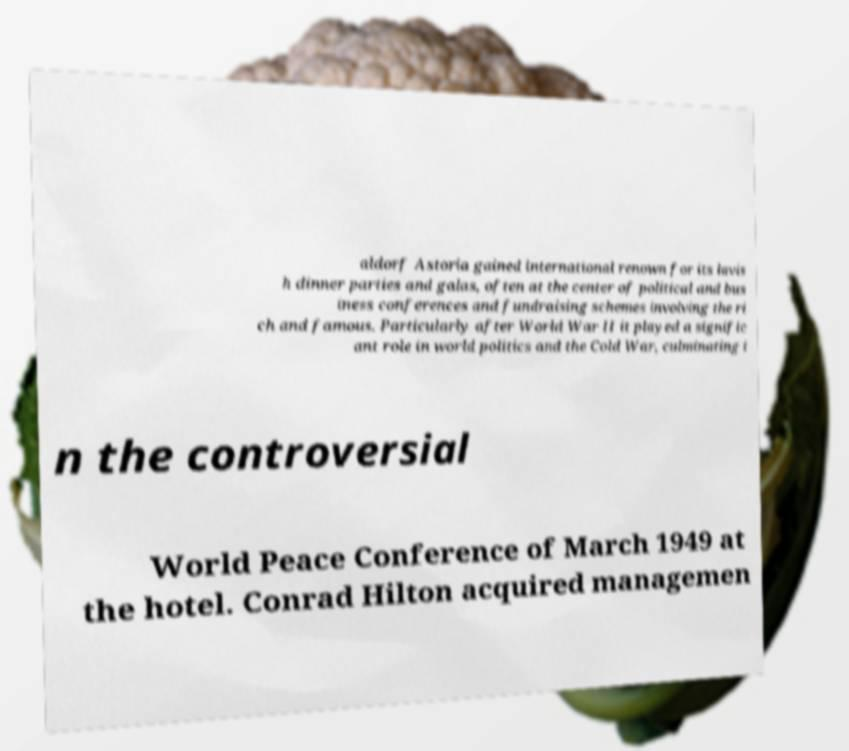Could you extract and type out the text from this image? aldorf Astoria gained international renown for its lavis h dinner parties and galas, often at the center of political and bus iness conferences and fundraising schemes involving the ri ch and famous. Particularly after World War II it played a signific ant role in world politics and the Cold War, culminating i n the controversial World Peace Conference of March 1949 at the hotel. Conrad Hilton acquired managemen 